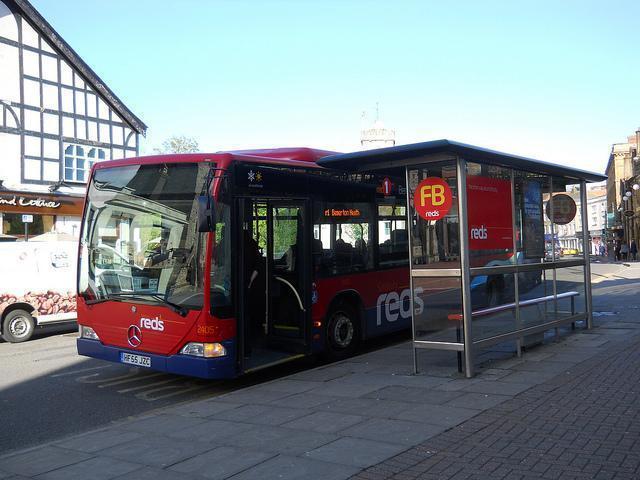What reason is the glass structure placed here?
From the following set of four choices, select the accurate answer to respond to the question.
Options: Bus stop, sales kiosk, advertising only, telephone calls. Bus stop. 